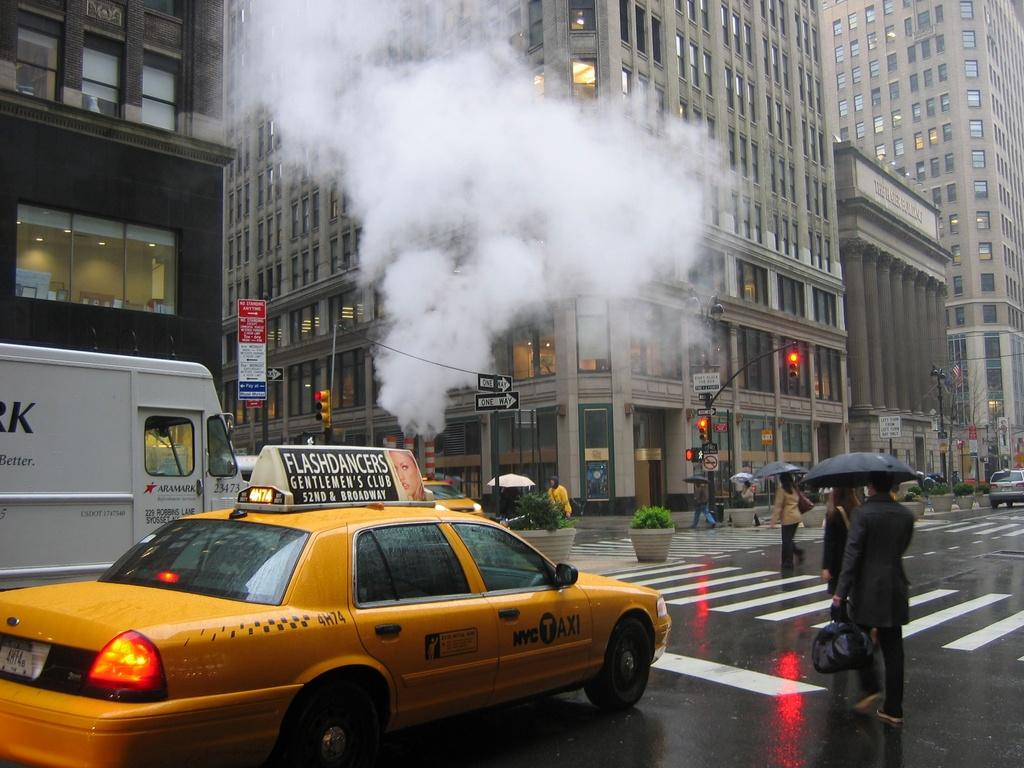Provide a one-sentence caption for the provided image. A taxi driving down a busy NY street; on the taxi there is an add for Flashdancer's gentlmens club/. 